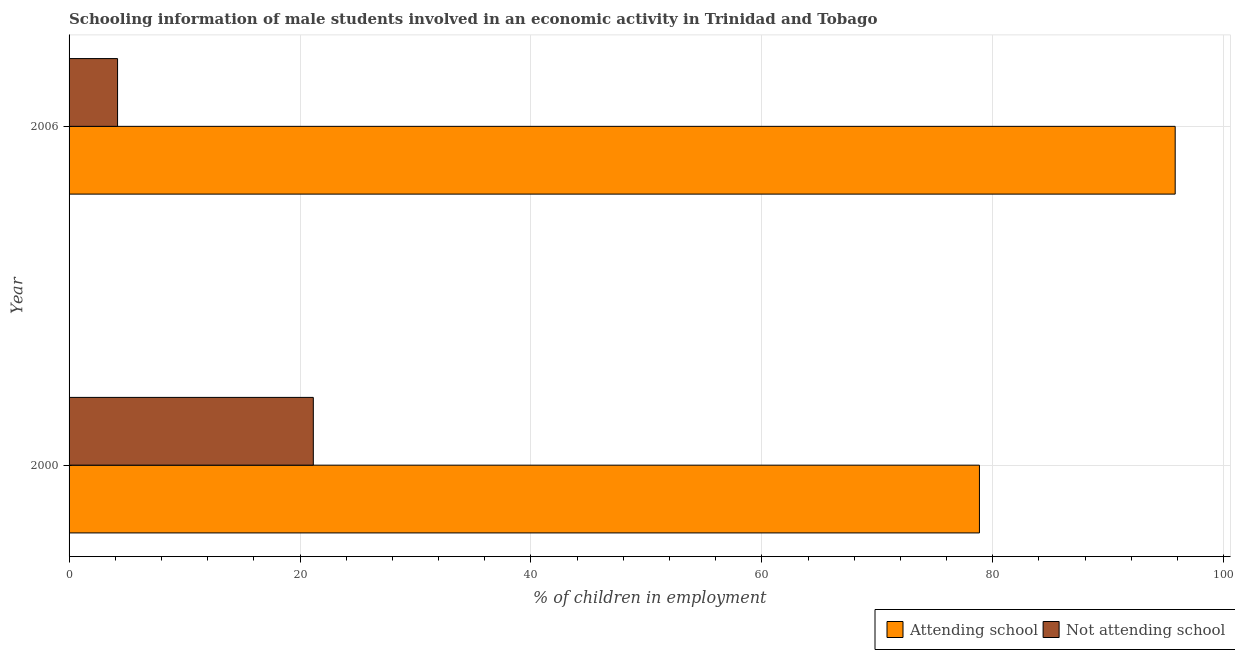How many different coloured bars are there?
Make the answer very short. 2. Are the number of bars per tick equal to the number of legend labels?
Provide a succinct answer. Yes. What is the percentage of employed males who are not attending school in 2000?
Provide a short and direct response. 21.15. Across all years, what is the maximum percentage of employed males who are attending school?
Ensure brevity in your answer.  95.8. Across all years, what is the minimum percentage of employed males who are attending school?
Provide a succinct answer. 78.85. In which year was the percentage of employed males who are not attending school minimum?
Your response must be concise. 2006. What is the total percentage of employed males who are not attending school in the graph?
Keep it short and to the point. 25.35. What is the difference between the percentage of employed males who are attending school in 2000 and that in 2006?
Your answer should be very brief. -16.95. What is the difference between the percentage of employed males who are attending school in 2000 and the percentage of employed males who are not attending school in 2006?
Your answer should be very brief. 74.65. What is the average percentage of employed males who are attending school per year?
Offer a terse response. 87.32. In the year 2006, what is the difference between the percentage of employed males who are attending school and percentage of employed males who are not attending school?
Your answer should be compact. 91.6. What is the ratio of the percentage of employed males who are not attending school in 2000 to that in 2006?
Give a very brief answer. 5.04. What does the 2nd bar from the top in 2006 represents?
Make the answer very short. Attending school. What does the 1st bar from the bottom in 2006 represents?
Offer a terse response. Attending school. What is the difference between two consecutive major ticks on the X-axis?
Offer a very short reply. 20. Are the values on the major ticks of X-axis written in scientific E-notation?
Your response must be concise. No. Does the graph contain any zero values?
Your answer should be very brief. No. Does the graph contain grids?
Ensure brevity in your answer.  Yes. Where does the legend appear in the graph?
Provide a succinct answer. Bottom right. How many legend labels are there?
Your answer should be very brief. 2. How are the legend labels stacked?
Offer a terse response. Horizontal. What is the title of the graph?
Ensure brevity in your answer.  Schooling information of male students involved in an economic activity in Trinidad and Tobago. Does "Quality of trade" appear as one of the legend labels in the graph?
Your answer should be very brief. No. What is the label or title of the X-axis?
Ensure brevity in your answer.  % of children in employment. What is the label or title of the Y-axis?
Provide a succinct answer. Year. What is the % of children in employment in Attending school in 2000?
Offer a terse response. 78.85. What is the % of children in employment of Not attending school in 2000?
Ensure brevity in your answer.  21.15. What is the % of children in employment in Attending school in 2006?
Offer a terse response. 95.8. Across all years, what is the maximum % of children in employment in Attending school?
Ensure brevity in your answer.  95.8. Across all years, what is the maximum % of children in employment of Not attending school?
Your answer should be very brief. 21.15. Across all years, what is the minimum % of children in employment in Attending school?
Provide a succinct answer. 78.85. Across all years, what is the minimum % of children in employment in Not attending school?
Make the answer very short. 4.2. What is the total % of children in employment of Attending school in the graph?
Give a very brief answer. 174.65. What is the total % of children in employment in Not attending school in the graph?
Ensure brevity in your answer.  25.35. What is the difference between the % of children in employment of Attending school in 2000 and that in 2006?
Your answer should be compact. -16.95. What is the difference between the % of children in employment in Not attending school in 2000 and that in 2006?
Offer a very short reply. 16.95. What is the difference between the % of children in employment of Attending school in 2000 and the % of children in employment of Not attending school in 2006?
Your answer should be compact. 74.65. What is the average % of children in employment in Attending school per year?
Your answer should be very brief. 87.32. What is the average % of children in employment in Not attending school per year?
Your response must be concise. 12.68. In the year 2000, what is the difference between the % of children in employment in Attending school and % of children in employment in Not attending school?
Your response must be concise. 57.69. In the year 2006, what is the difference between the % of children in employment in Attending school and % of children in employment in Not attending school?
Provide a short and direct response. 91.6. What is the ratio of the % of children in employment of Attending school in 2000 to that in 2006?
Keep it short and to the point. 0.82. What is the ratio of the % of children in employment in Not attending school in 2000 to that in 2006?
Provide a short and direct response. 5.04. What is the difference between the highest and the second highest % of children in employment in Attending school?
Give a very brief answer. 16.95. What is the difference between the highest and the second highest % of children in employment in Not attending school?
Provide a succinct answer. 16.95. What is the difference between the highest and the lowest % of children in employment of Attending school?
Provide a short and direct response. 16.95. What is the difference between the highest and the lowest % of children in employment of Not attending school?
Give a very brief answer. 16.95. 